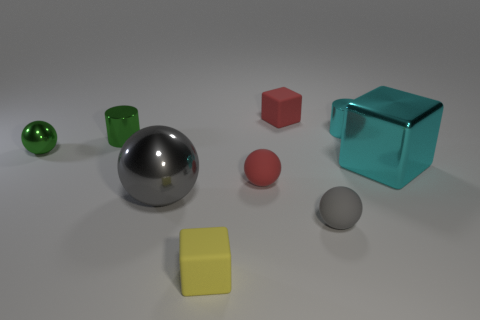Subtract 1 balls. How many balls are left? 3 Subtract all brown spheres. Subtract all purple blocks. How many spheres are left? 4 Add 1 tiny cylinders. How many objects exist? 10 Subtract all spheres. How many objects are left? 5 Add 7 cyan metal objects. How many cyan metal objects exist? 9 Subtract 0 purple cylinders. How many objects are left? 9 Subtract all red rubber spheres. Subtract all gray shiny balls. How many objects are left? 7 Add 4 gray things. How many gray things are left? 6 